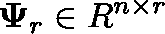<formula> <loc_0><loc_0><loc_500><loc_500>\Psi _ { r } \in \mathbb { R } ^ { n \times r }</formula> 